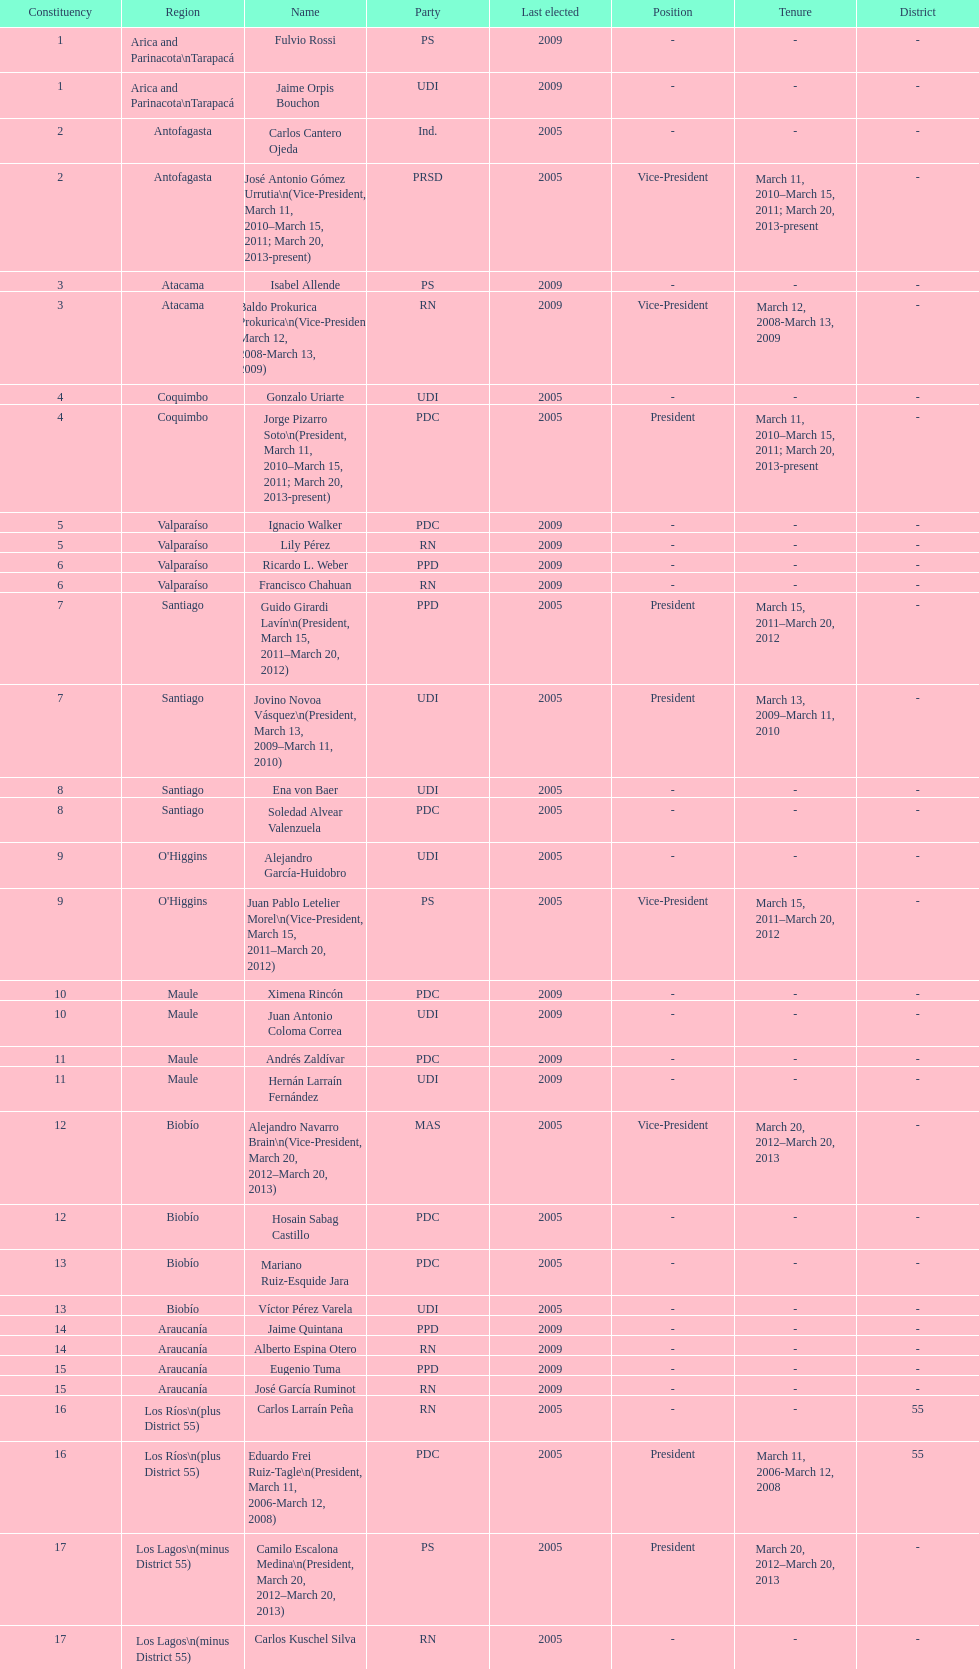What is the difference in years between constiuency 1 and 2? 4 years. 